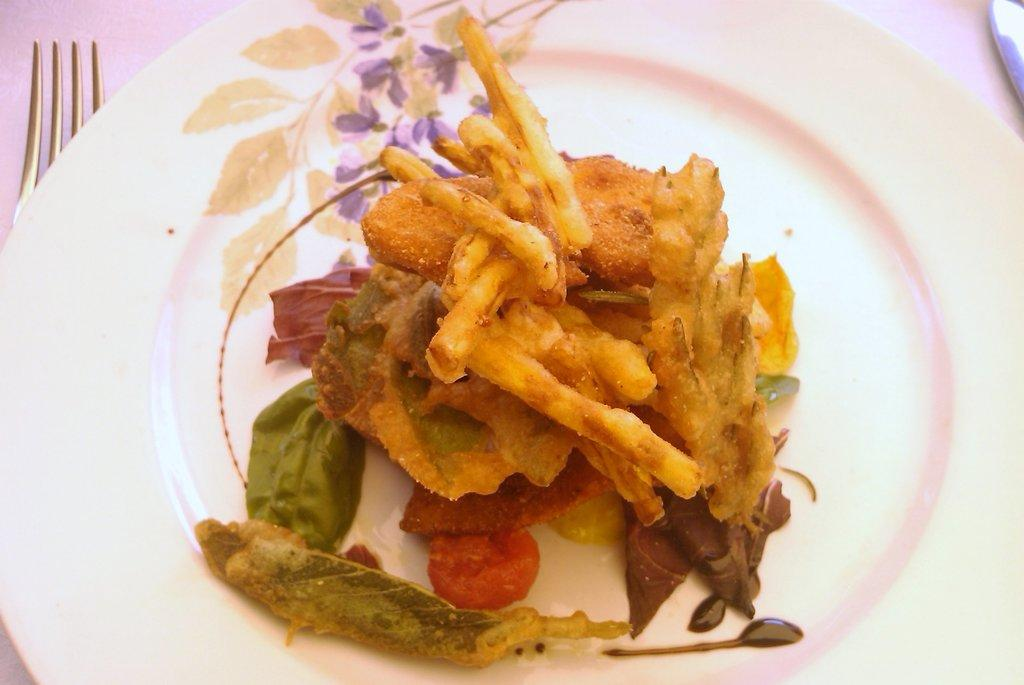What is on the plate in the image? There is food on a plate in the image. Can you describe any utensils visible in the image? A partial part of a fork is visible on the left side of the image. What is located on the right side of the image? There is an object on the right side of the image. What type of jeans is the wren wearing in the image? There is no wren or jeans present in the image. 